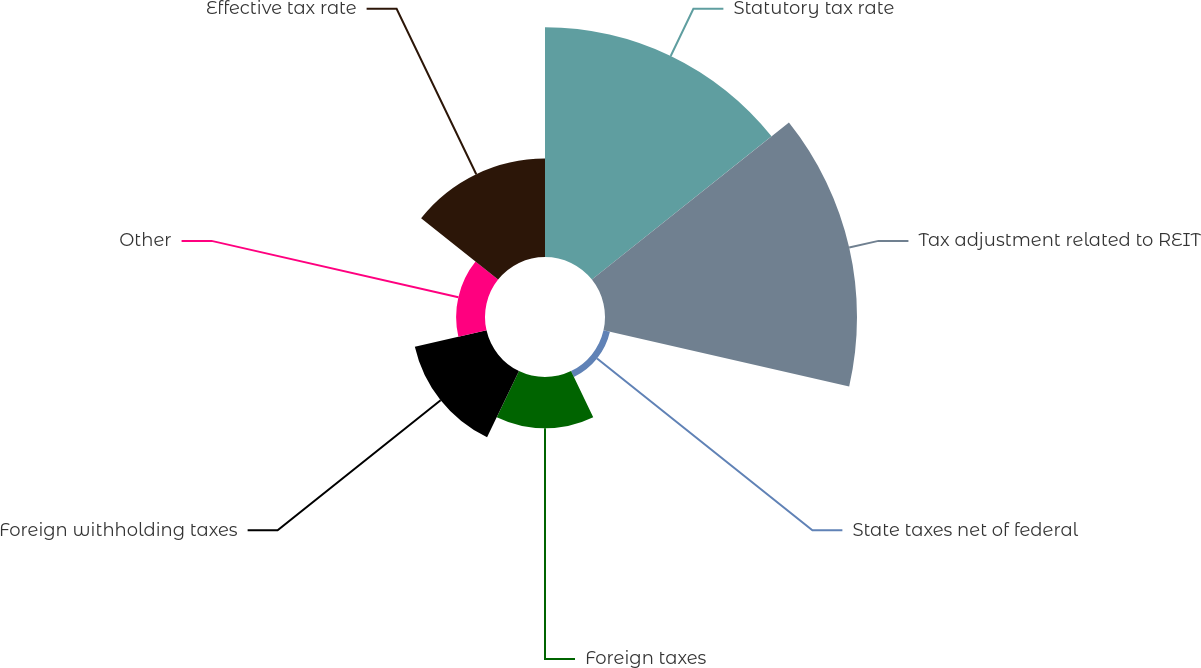Convert chart to OTSL. <chart><loc_0><loc_0><loc_500><loc_500><pie_chart><fcel>Statutory tax rate<fcel>Tax adjustment related to REIT<fcel>State taxes net of federal<fcel>Foreign taxes<fcel>Foreign withholding taxes<fcel>Other<fcel>Effective tax rate<nl><fcel>31.03%<fcel>34.04%<fcel>0.89%<fcel>6.91%<fcel>9.93%<fcel>3.9%<fcel>13.3%<nl></chart> 